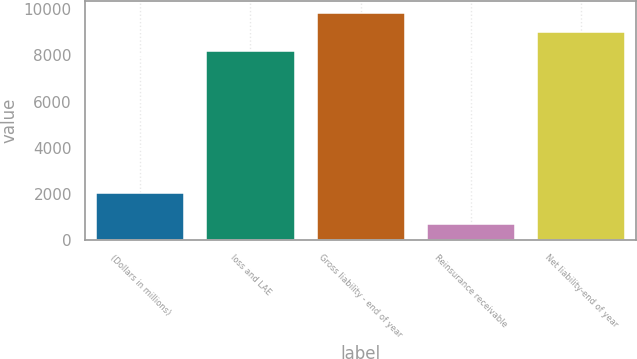Convert chart. <chart><loc_0><loc_0><loc_500><loc_500><bar_chart><fcel>(Dollars in millions)<fcel>loss and LAE<fcel>Gross liability - end of year<fcel>Reinsurance receivable<fcel>Net liability-end of year<nl><fcel>2008<fcel>8214.7<fcel>9857.64<fcel>691.2<fcel>9036.17<nl></chart> 